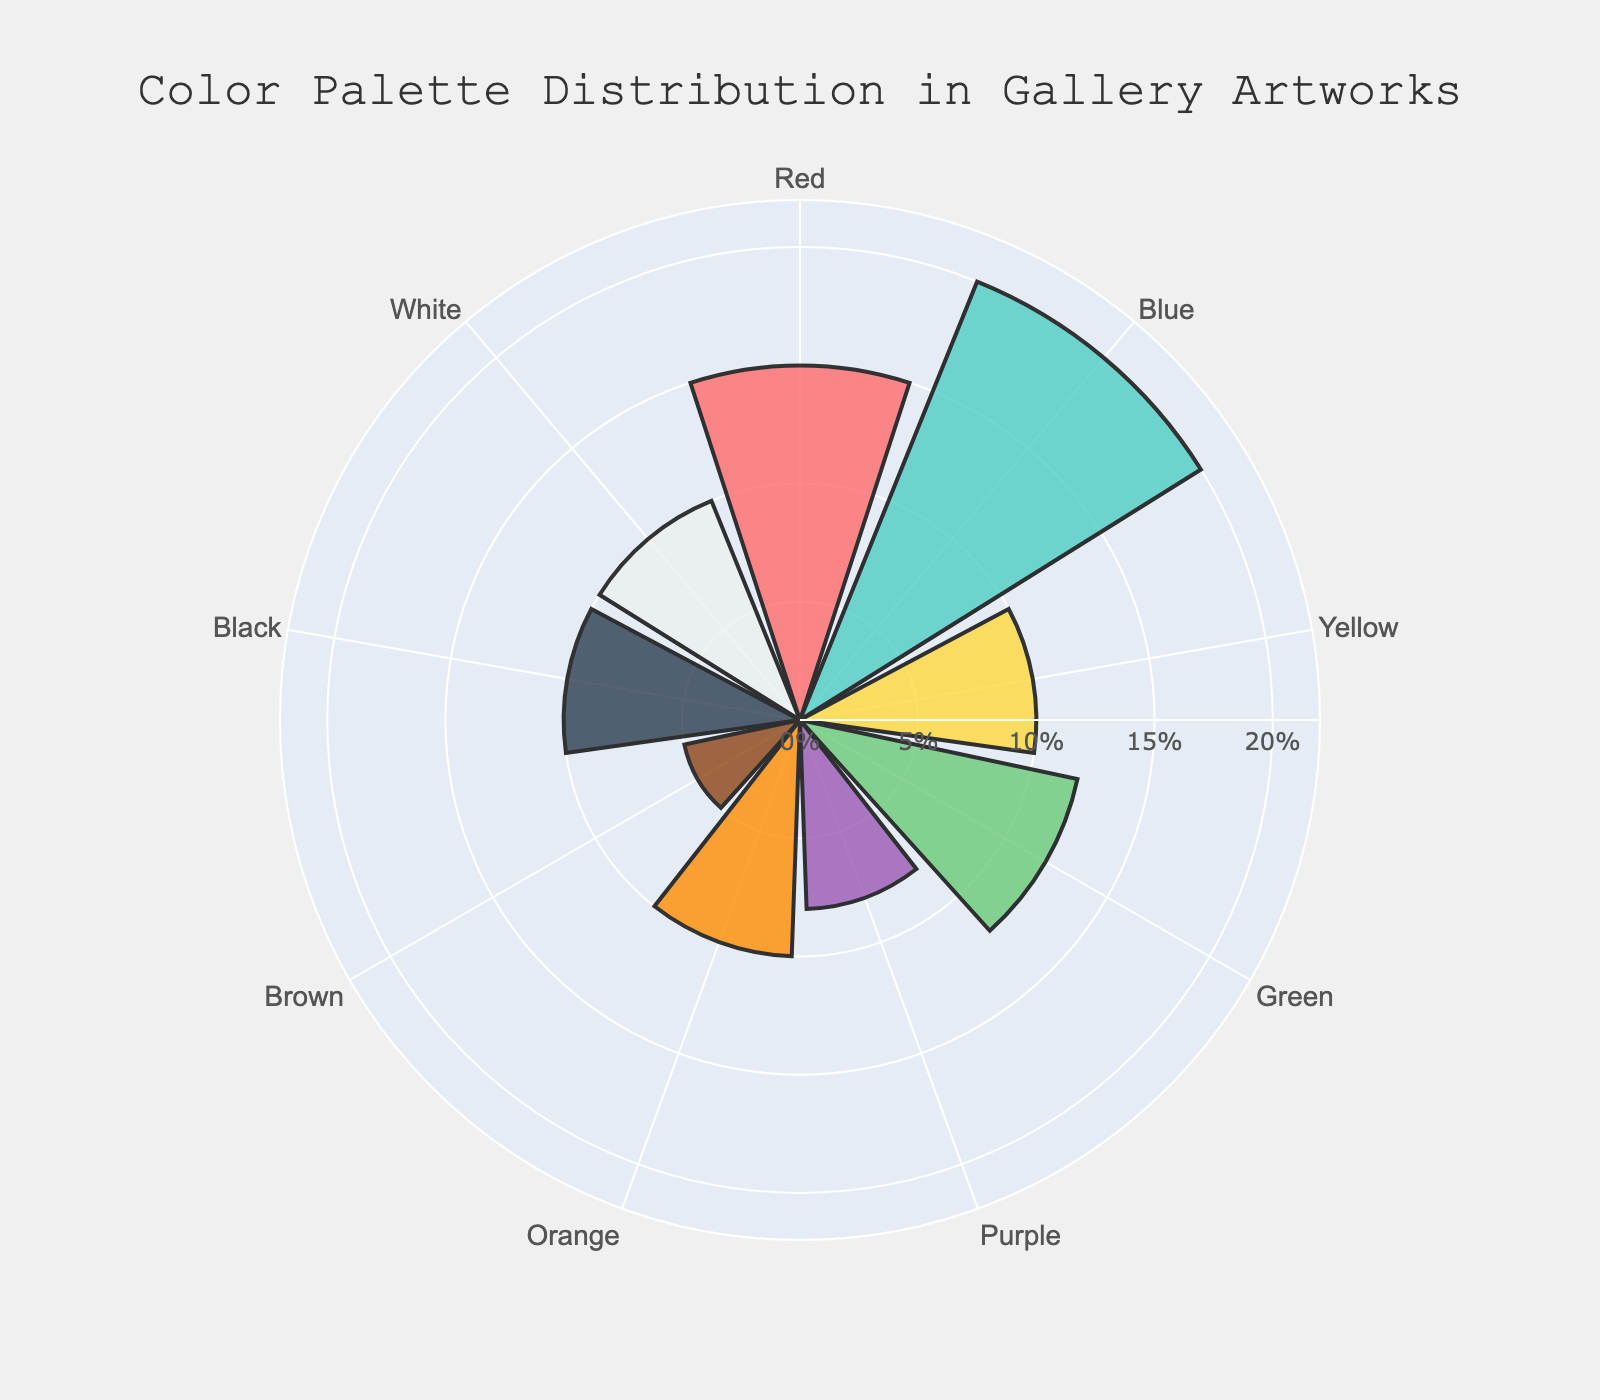What's the title of the figure? The title is located at the top of the figure and provides a summary of what the chart represents.
Answer: Color Palette Distribution in Gallery Artworks Which color has the highest percentage distribution? To determine this, look at the bars' lengths and locate the one with the maximum value.
Answer: Blue How many colors have a percentage distribution of 10%? Identify all the bars that have a radial length of 10%.
Answer: Four colors (Yellow, Orange, Black, White) What is the combined percentage distribution of Red and Green? Find the percentage values for Red and Green, and add them together: Red (15%) + Green (12%) = 27%.
Answer: 27% Which color has the lowest representation? Look for the bar that is shortest; this corresponds to the lowest percentage.
Answer: Brown Is the percentage distribution of White and Black equal? Compare the lengths of the bars for White and Black. Both have a radial length of 10%.
Answer: Yes How much greater is the percentage distribution of Blue compared to Purple? Subtract Purple's percentage from Blue's percentage: Blue (20%) - Purple (8%) = 12%.
Answer: 12% What is the average percentage distribution of all the colors? Sum all the percentage values and divide by the number of colors. (15 + 20 + 10 + 12 + 8 + 10 + 5 + 10 + 10) / 9 = 100 / 9 ≈ 11.11%.
Answer: 11.11% Rank the top three colors by their percentage distribution. Identify the bars with the three greatest lengths and arrange them in descending order. Blue (20%), Red (15%), Green (12%).
Answer: Blue, Red, Green What percentage does Orange represent in the chart? Locate the bar for Orange and read its percentage value.
Answer: 10% 